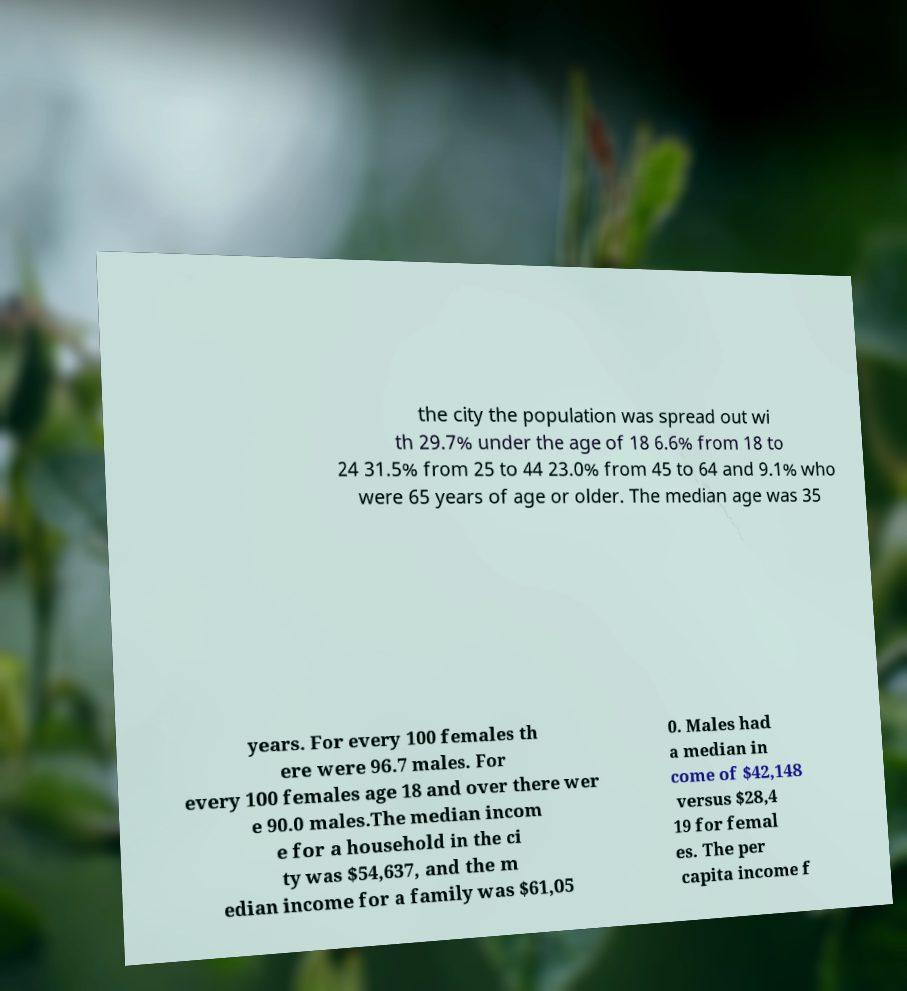For documentation purposes, I need the text within this image transcribed. Could you provide that? the city the population was spread out wi th 29.7% under the age of 18 6.6% from 18 to 24 31.5% from 25 to 44 23.0% from 45 to 64 and 9.1% who were 65 years of age or older. The median age was 35 years. For every 100 females th ere were 96.7 males. For every 100 females age 18 and over there wer e 90.0 males.The median incom e for a household in the ci ty was $54,637, and the m edian income for a family was $61,05 0. Males had a median in come of $42,148 versus $28,4 19 for femal es. The per capita income f 